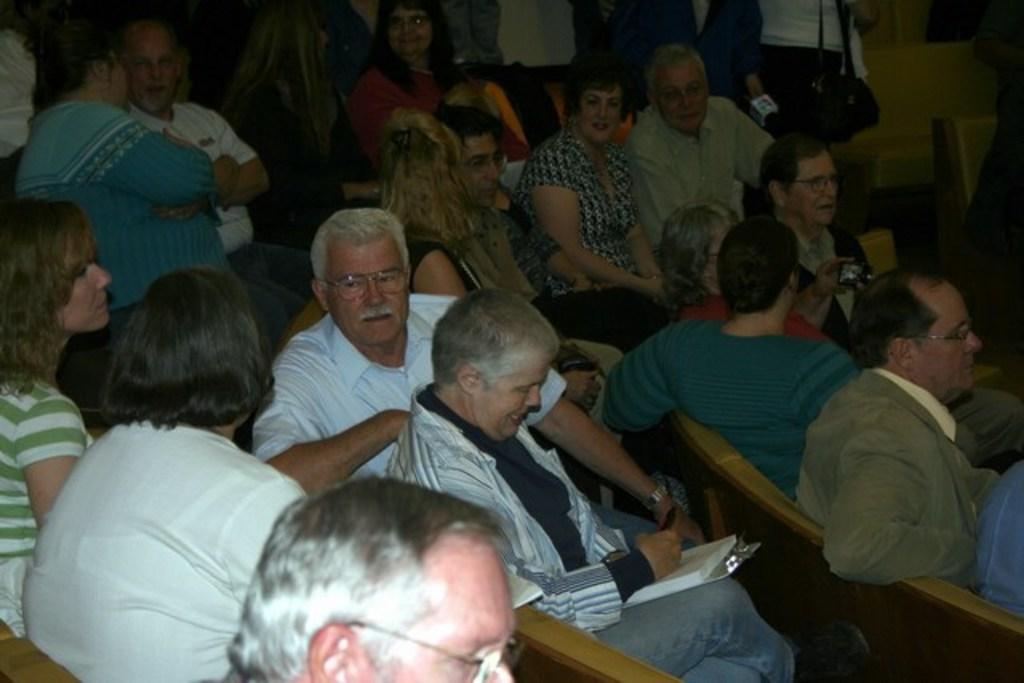In one or two sentences, can you explain what this image depicts? In this picture there is an old man who is wearing spectacle and white shirt. Beside him we can see woman who is holding a book. Both of them are sitting on the bench. Here we can see a group of persons were standing near to the wall. On the right there is a man who is sitting near to the person who is wearing green t-shirt. 